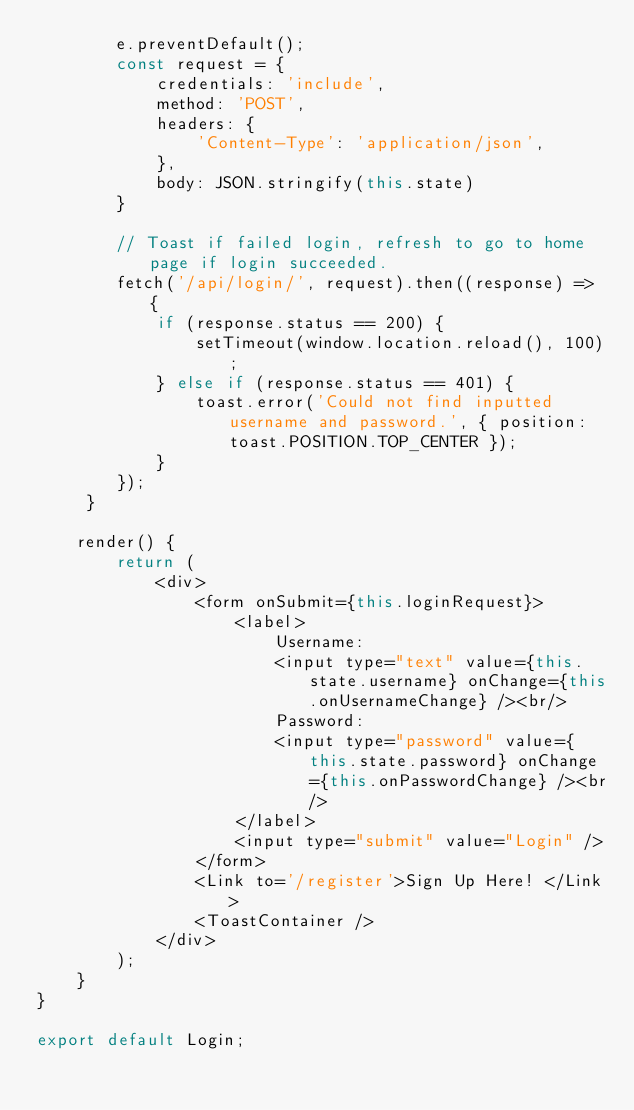<code> <loc_0><loc_0><loc_500><loc_500><_JavaScript_>        e.preventDefault();
        const request = {
            credentials: 'include',
            method: 'POST',
            headers: {
                'Content-Type': 'application/json',
            },
            body: JSON.stringify(this.state)
        }

        // Toast if failed login, refresh to go to home page if login succeeded.
        fetch('/api/login/', request).then((response) => {
            if (response.status == 200) {
                setTimeout(window.location.reload(), 100);
            } else if (response.status == 401) {
                toast.error('Could not find inputted username and password.', { position: toast.POSITION.TOP_CENTER });
            }
        });
     }

    render() {
        return (
            <div>
                <form onSubmit={this.loginRequest}>
                    <label>
                        Username:
                        <input type="text" value={this.state.username} onChange={this.onUsernameChange} /><br/>
                        Password:
                        <input type="password" value={this.state.password} onChange={this.onPasswordChange} /><br/>
                    </label>
                    <input type="submit" value="Login" />
                </form>
                <Link to='/register'>Sign Up Here! </Link>
                <ToastContainer />
            </div>
        );
    }
}

export default Login;</code> 